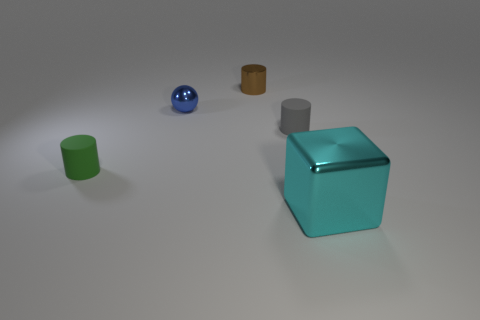What is the color of the tiny metal ball?
Give a very brief answer. Blue. There is a cylinder to the left of the tiny metal ball; are there any cyan shiny blocks that are behind it?
Provide a succinct answer. No. The shiny object in front of the small matte cylinder behind the green rubber cylinder is what shape?
Ensure brevity in your answer.  Cube. Is the number of brown metallic cylinders less than the number of small cyan things?
Your answer should be very brief. No. Do the blue thing and the brown cylinder have the same material?
Keep it short and to the point. Yes. There is a metal object that is in front of the brown shiny thing and behind the large shiny block; what color is it?
Give a very brief answer. Blue. Is there a cyan metal object of the same size as the brown cylinder?
Your response must be concise. No. What is the size of the metal thing that is in front of the matte object in front of the small gray object?
Make the answer very short. Large. Are there fewer matte cylinders that are to the left of the shiny ball than large blue shiny blocks?
Make the answer very short. No. Does the metal cube have the same color as the sphere?
Make the answer very short. No. 